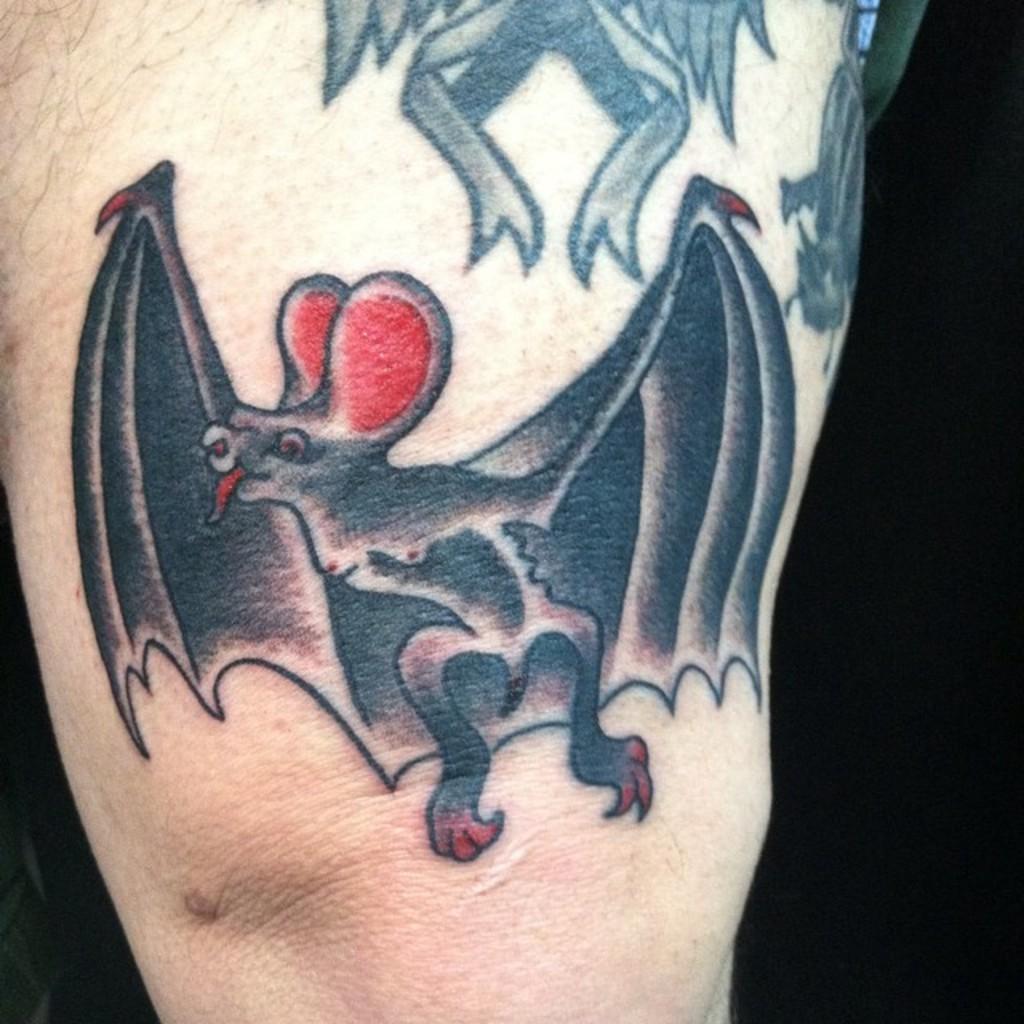Could you give a brief overview of what you see in this image? In this image we can see a tattoo on the person's hand. 